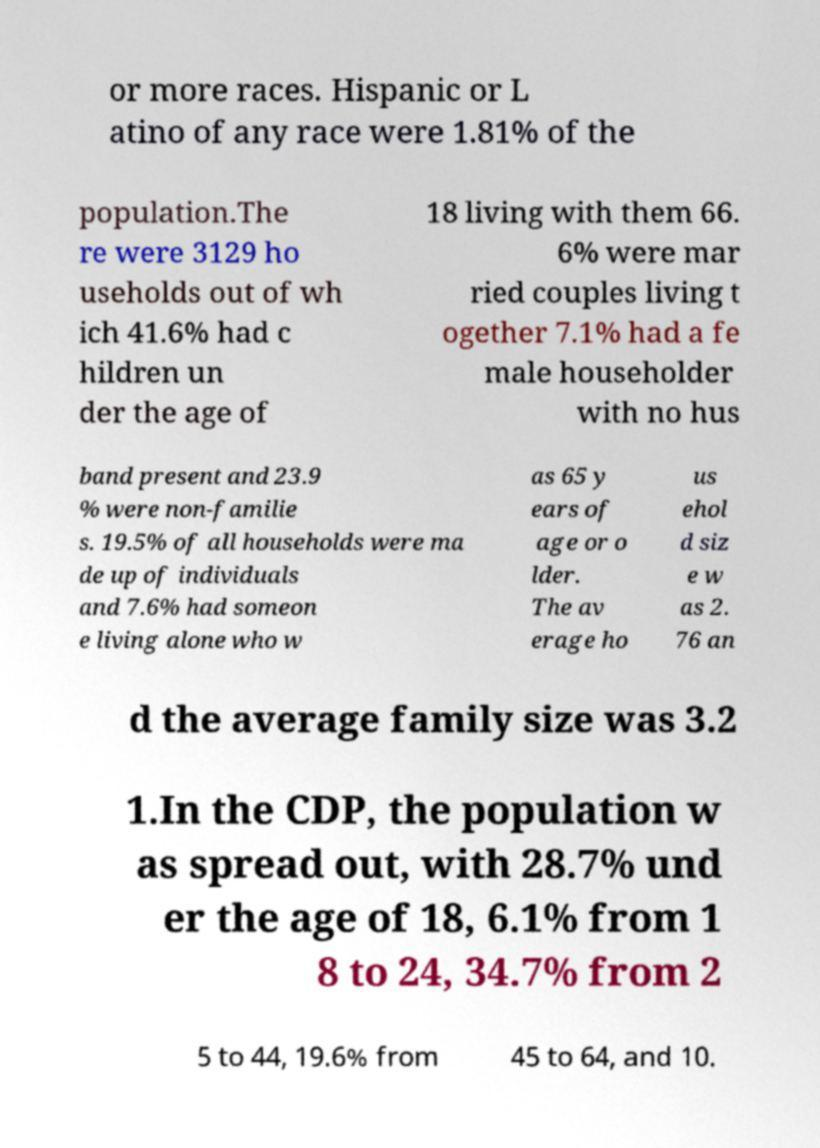Please read and relay the text visible in this image. What does it say? or more races. Hispanic or L atino of any race were 1.81% of the population.The re were 3129 ho useholds out of wh ich 41.6% had c hildren un der the age of 18 living with them 66. 6% were mar ried couples living t ogether 7.1% had a fe male householder with no hus band present and 23.9 % were non-familie s. 19.5% of all households were ma de up of individuals and 7.6% had someon e living alone who w as 65 y ears of age or o lder. The av erage ho us ehol d siz e w as 2. 76 an d the average family size was 3.2 1.In the CDP, the population w as spread out, with 28.7% und er the age of 18, 6.1% from 1 8 to 24, 34.7% from 2 5 to 44, 19.6% from 45 to 64, and 10. 